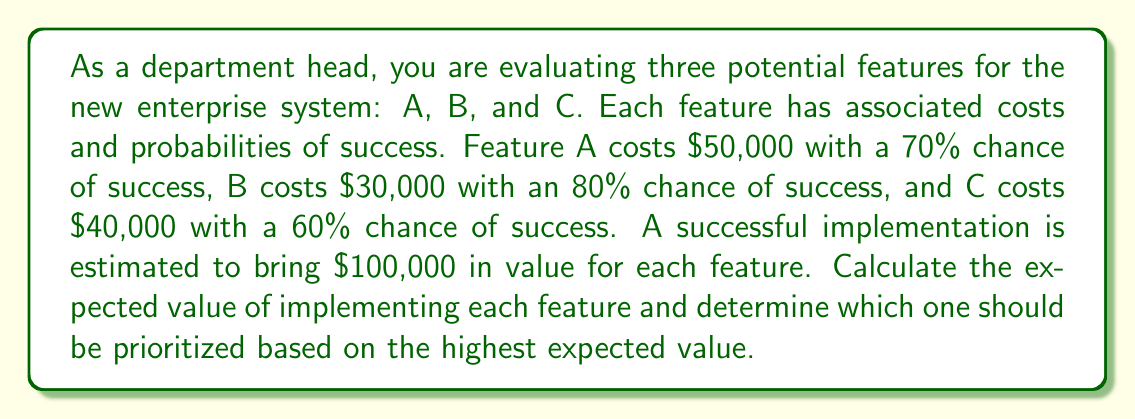Teach me how to tackle this problem. To solve this problem, we need to calculate the expected value for each feature using the formula:

$$ EV = (P_{success} \times V_{success}) - C_{implementation} $$

Where:
$EV$ is the Expected Value
$P_{success}$ is the Probability of Success
$V_{success}$ is the Value of Success
$C_{implementation}$ is the Cost of Implementation

Let's calculate the expected value for each feature:

1. Feature A:
   $$ EV_A = (0.70 \times \$100,000) - \$50,000 $$
   $$ EV_A = \$70,000 - \$50,000 = \$20,000 $$

2. Feature B:
   $$ EV_B = (0.80 \times \$100,000) - \$30,000 $$
   $$ EV_B = \$80,000 - \$30,000 = \$50,000 $$

3. Feature C:
   $$ EV_C = (0.60 \times \$100,000) - \$40,000 $$
   $$ EV_C = \$60,000 - \$40,000 = \$20,000 $$

Comparing the expected values:
$EV_B > EV_A = EV_C$

Therefore, Feature B has the highest expected value and should be prioritized for implementation.
Answer: Feature B should be prioritized with an expected value of $50,000. 